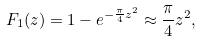Convert formula to latex. <formula><loc_0><loc_0><loc_500><loc_500>F _ { 1 } ( z ) = 1 - e ^ { - \frac { \pi } { 4 } z ^ { 2 } } \approx \frac { \pi } { 4 } z ^ { 2 } ,</formula> 